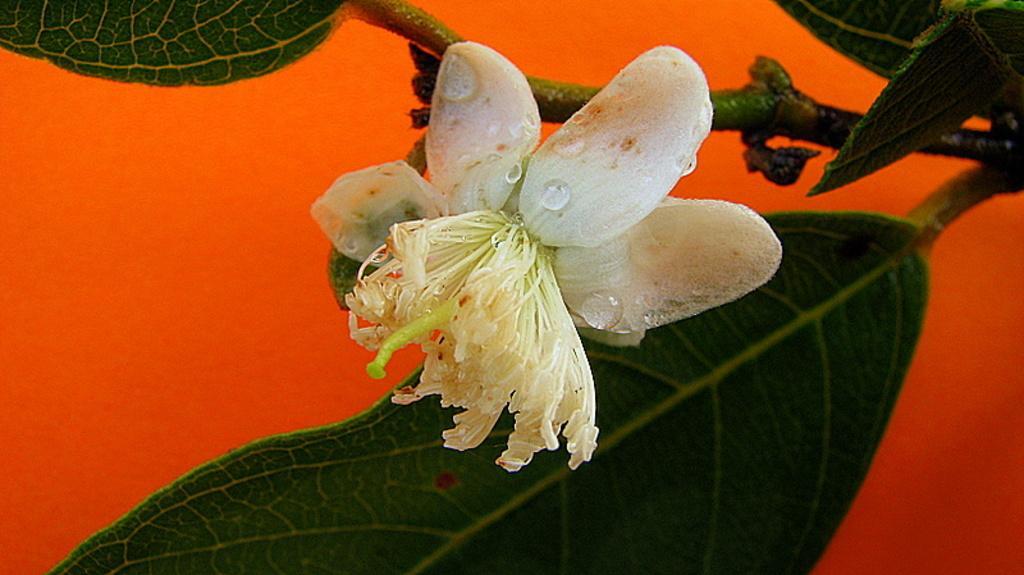In one or two sentences, can you explain what this image depicts? The picture consists of leaves, stems, flower. On the flower we can see water droplets. In the background it is red. 